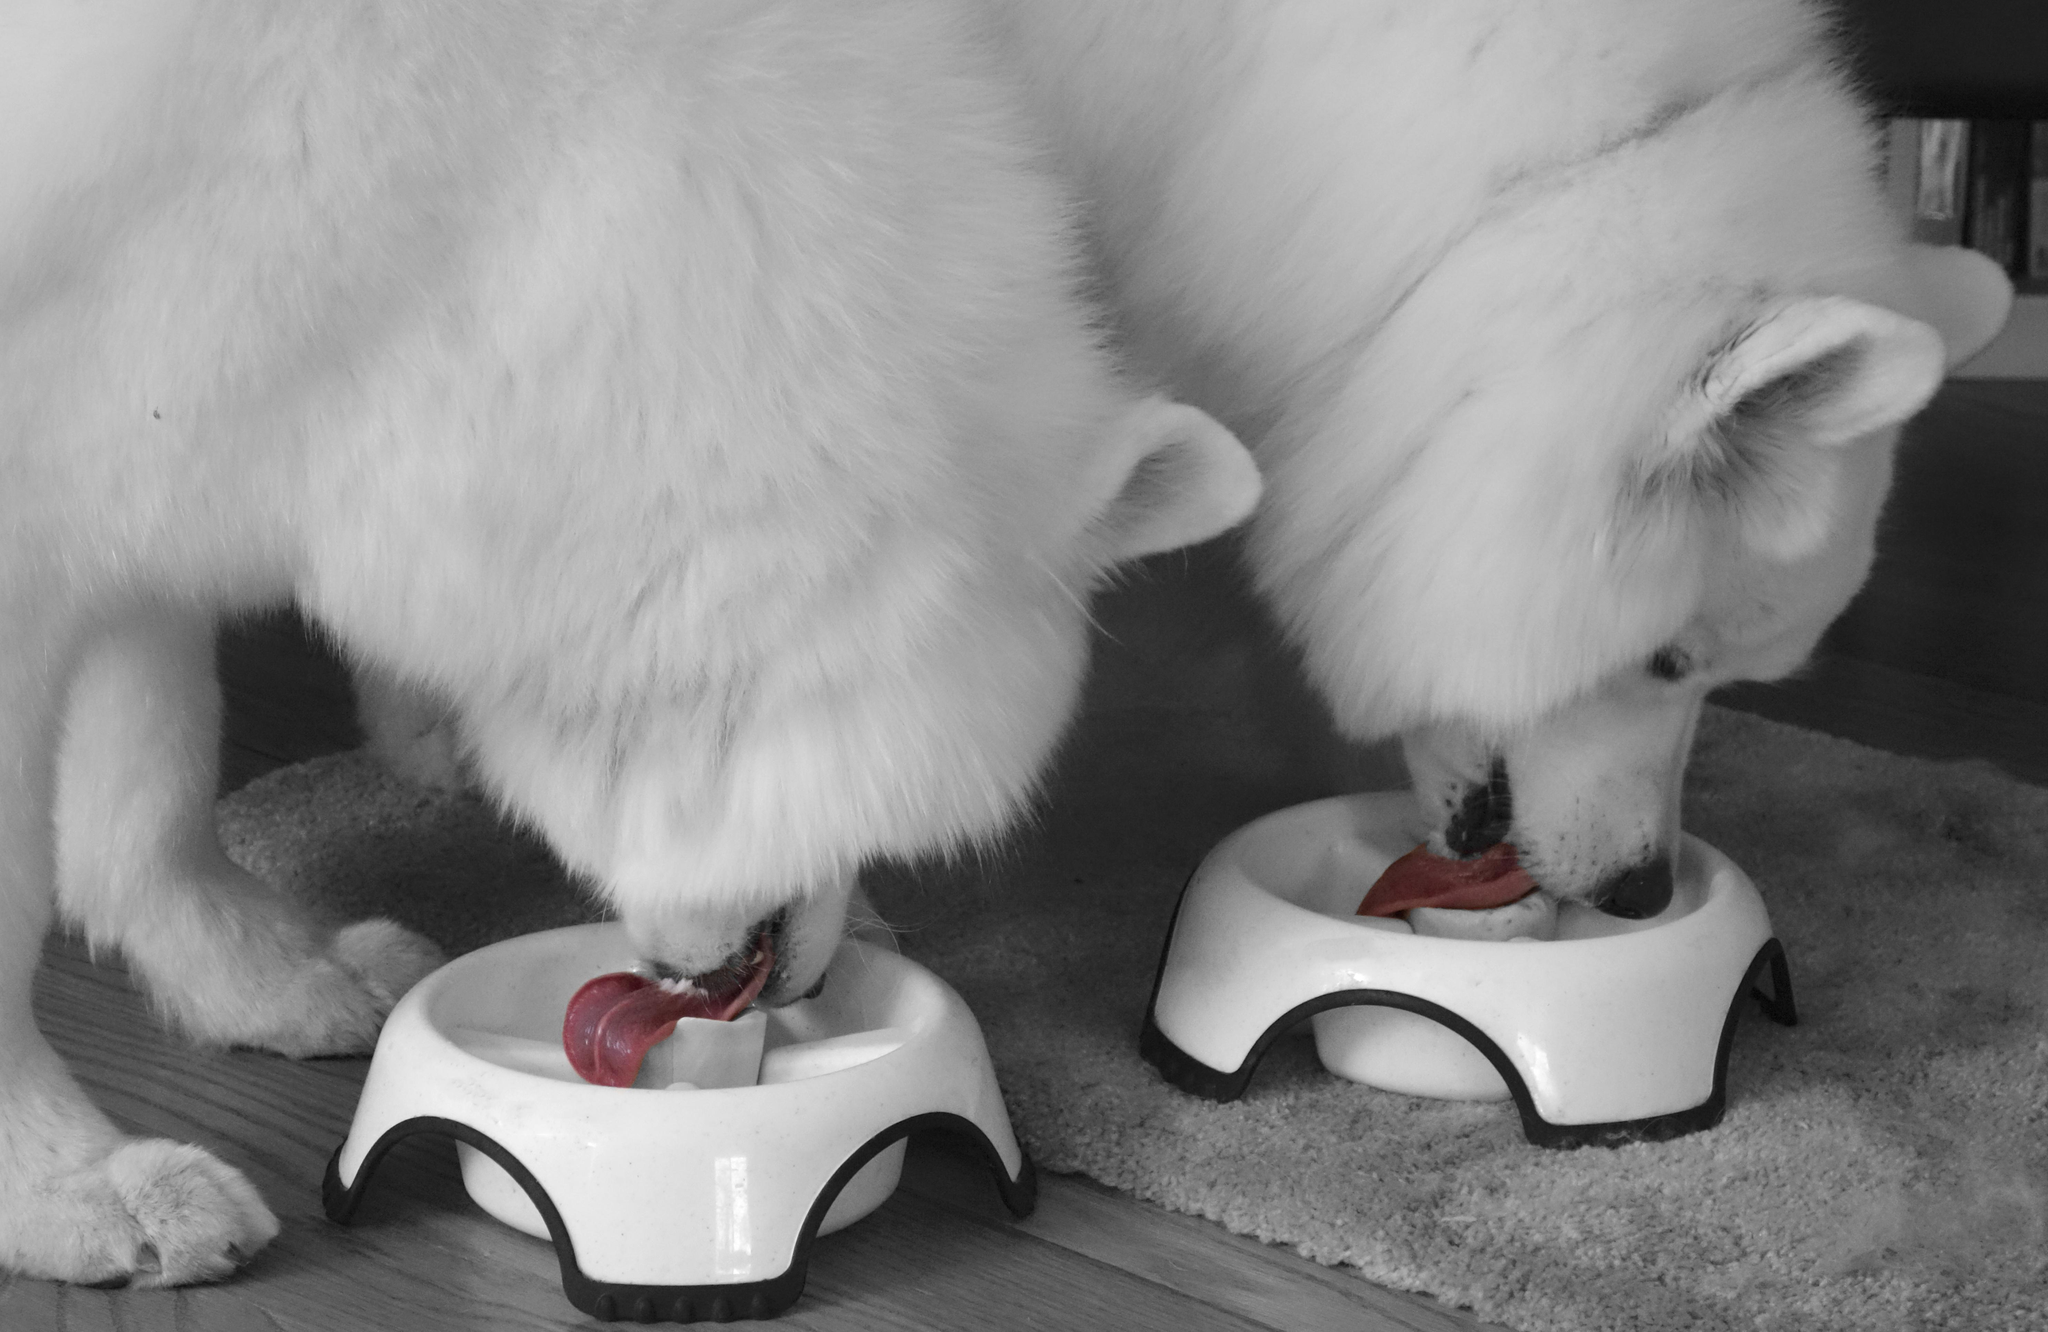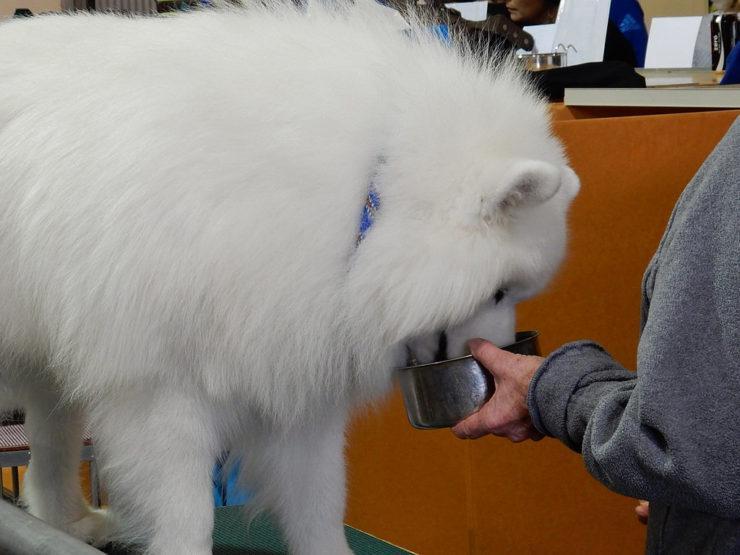The first image is the image on the left, the second image is the image on the right. Considering the images on both sides, is "There is a total of 2 Samoyed's sitting at a table." valid? Answer yes or no. No. The first image is the image on the left, the second image is the image on the right. Analyze the images presented: Is the assertion "a dog is sitting at the kitchen table" valid? Answer yes or no. No. 